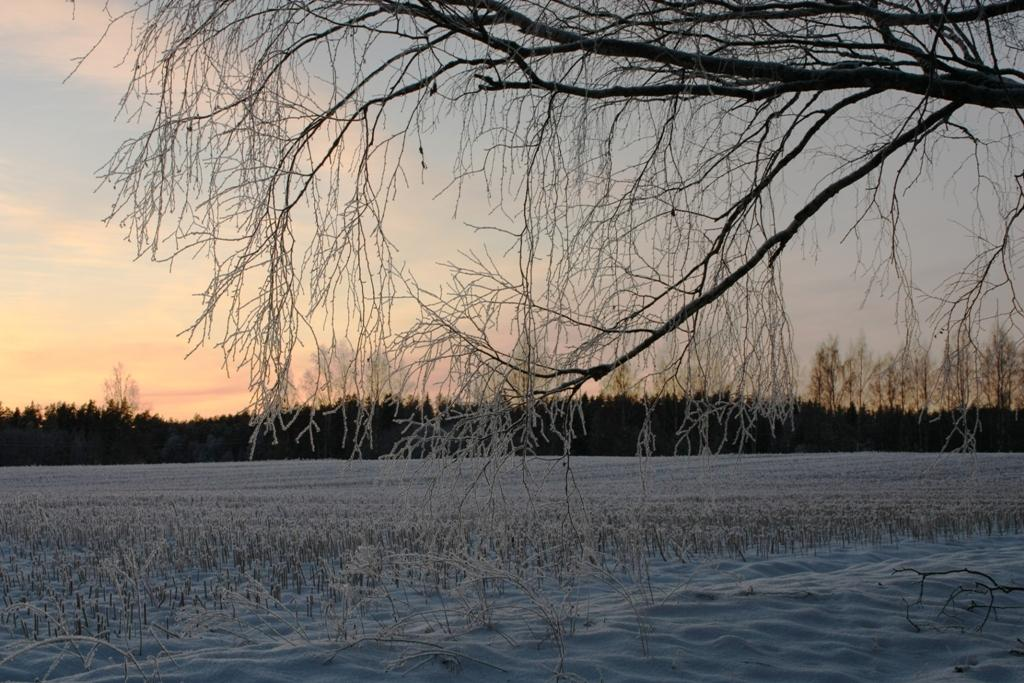What type of vegetation is present in the image? There is grass in the image. What can be seen in the front of the image? There is a tree in the front of the image. How many trees are visible in the background of the image? There are multiple trees in the background of the image. What is visible in the sky in the background of the image? There are clouds visible in the background of the image. What part of the natural environment is visible in the image? The sky is visible in the background of the image. What type of guitar is being played by the tree in the image? There is no guitar present in the image; it features trees and grass. What property does the tree own in the image? There is no indication of property ownership in the image, as trees do not own property. 